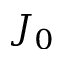<formula> <loc_0><loc_0><loc_500><loc_500>J _ { 0 }</formula> 